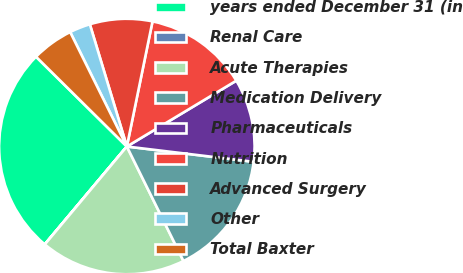Convert chart. <chart><loc_0><loc_0><loc_500><loc_500><pie_chart><fcel>years ended December 31 (in<fcel>Renal Care<fcel>Acute Therapies<fcel>Medication Delivery<fcel>Pharmaceuticals<fcel>Nutrition<fcel>Advanced Surgery<fcel>Other<fcel>Total Baxter<nl><fcel>26.3%<fcel>0.01%<fcel>18.41%<fcel>15.78%<fcel>10.53%<fcel>13.16%<fcel>7.9%<fcel>2.64%<fcel>5.27%<nl></chart> 